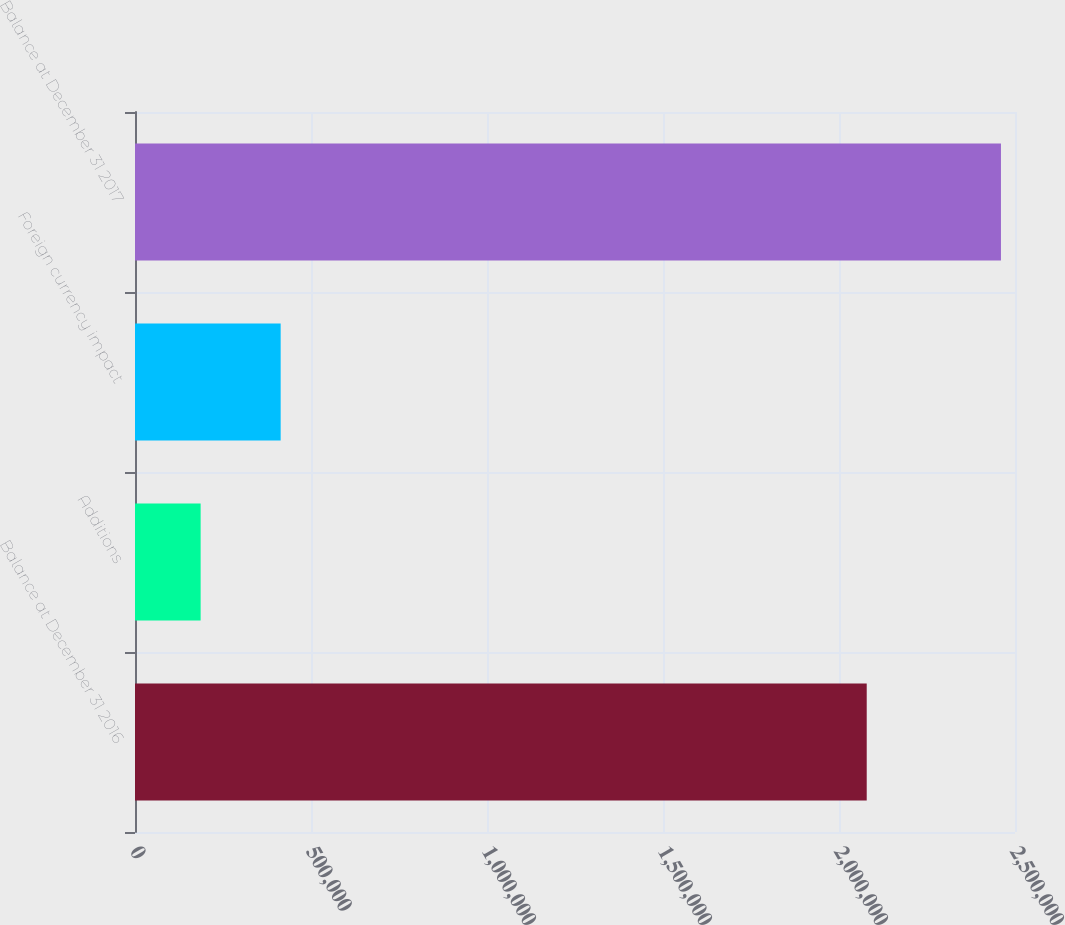<chart> <loc_0><loc_0><loc_500><loc_500><bar_chart><fcel>Balance at December 31 2016<fcel>Additions<fcel>Foreign currency impact<fcel>Balance at December 31 2017<nl><fcel>2.07876e+06<fcel>186487<fcel>413849<fcel>2.4601e+06<nl></chart> 